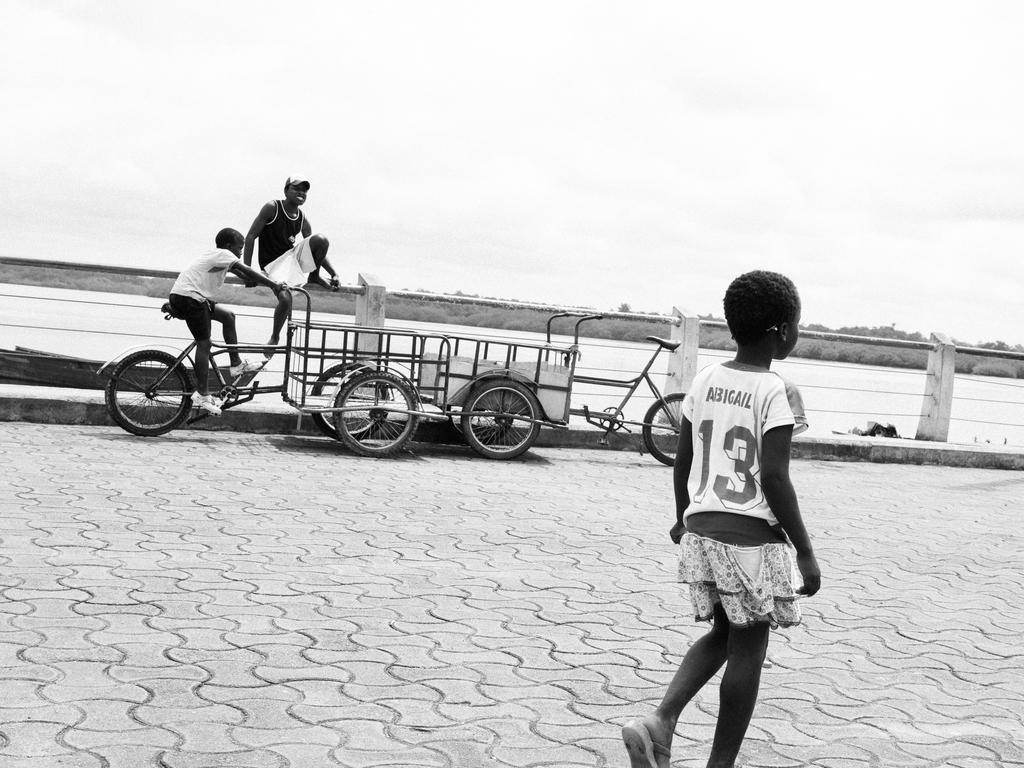In one or two sentences, can you explain what this image depicts? This is a black and white image and here we can see people and one of them is sitting on the railing and wearing a cap and there is a person riding a four wheeler and we can see an other bicycle. At the top, there is sky and at the bottom, there is water and a road. 